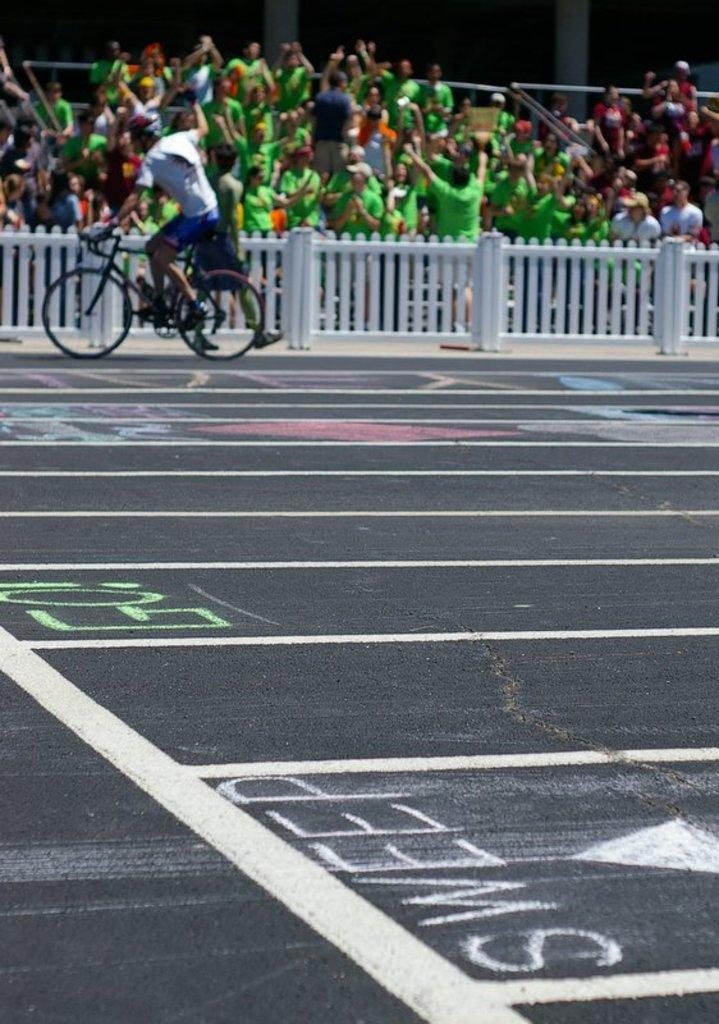What is the man in the image doing? The man is riding a bicycle in the image. Where is the man riding the bicycle? The man is on the road. What can be seen in the image besides the man on the bicycle? There is a fence and groups of people in the background of the image. Who is the owner of the planes in the image? There are no planes present in the image. 